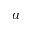Convert formula to latex. <formula><loc_0><loc_0><loc_500><loc_500>a</formula> 